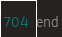Convert code to text. <code><loc_0><loc_0><loc_500><loc_500><_Crystal_>end</code> 